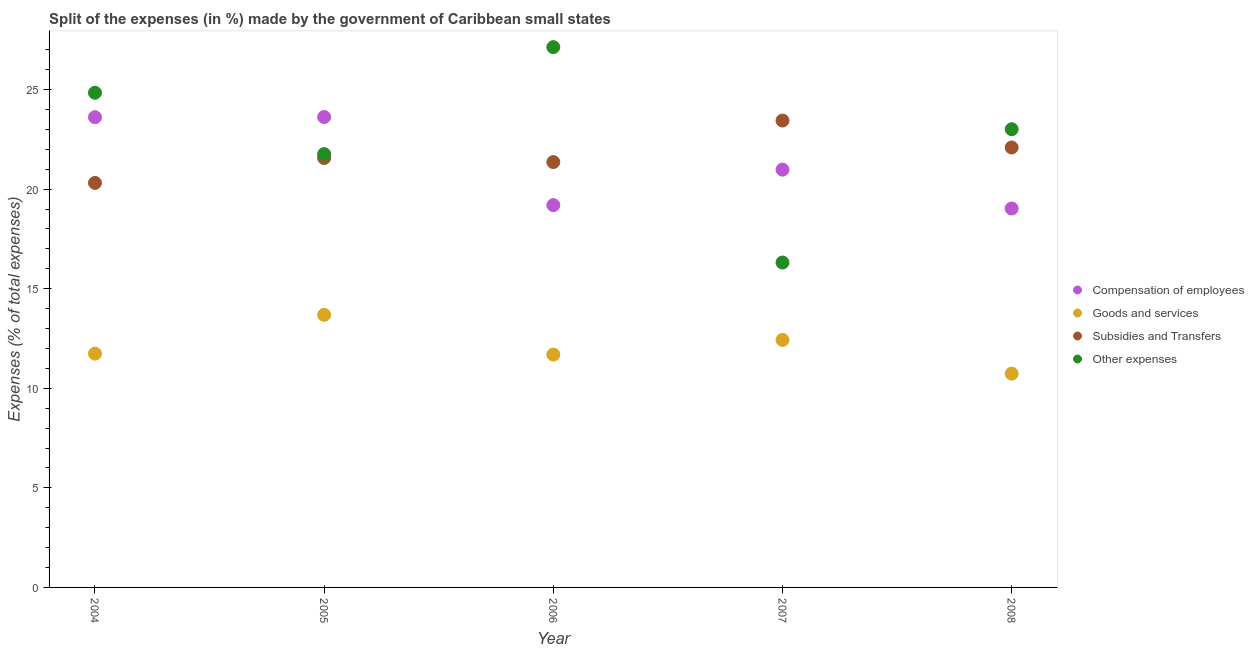How many different coloured dotlines are there?
Ensure brevity in your answer.  4. Is the number of dotlines equal to the number of legend labels?
Make the answer very short. Yes. What is the percentage of amount spent on goods and services in 2006?
Ensure brevity in your answer.  11.69. Across all years, what is the maximum percentage of amount spent on other expenses?
Give a very brief answer. 27.13. Across all years, what is the minimum percentage of amount spent on subsidies?
Offer a terse response. 20.31. In which year was the percentage of amount spent on goods and services maximum?
Make the answer very short. 2005. In which year was the percentage of amount spent on compensation of employees minimum?
Your answer should be compact. 2008. What is the total percentage of amount spent on other expenses in the graph?
Your answer should be compact. 113.04. What is the difference between the percentage of amount spent on goods and services in 2004 and that in 2007?
Make the answer very short. -0.69. What is the difference between the percentage of amount spent on compensation of employees in 2007 and the percentage of amount spent on other expenses in 2004?
Provide a succinct answer. -3.86. What is the average percentage of amount spent on other expenses per year?
Your answer should be compact. 22.61. In the year 2008, what is the difference between the percentage of amount spent on compensation of employees and percentage of amount spent on goods and services?
Ensure brevity in your answer.  8.29. In how many years, is the percentage of amount spent on subsidies greater than 13 %?
Your response must be concise. 5. What is the ratio of the percentage of amount spent on compensation of employees in 2005 to that in 2008?
Give a very brief answer. 1.24. Is the percentage of amount spent on goods and services in 2006 less than that in 2007?
Keep it short and to the point. Yes. Is the difference between the percentage of amount spent on goods and services in 2004 and 2006 greater than the difference between the percentage of amount spent on other expenses in 2004 and 2006?
Offer a terse response. Yes. What is the difference between the highest and the second highest percentage of amount spent on other expenses?
Your response must be concise. 2.29. What is the difference between the highest and the lowest percentage of amount spent on other expenses?
Your answer should be compact. 10.81. In how many years, is the percentage of amount spent on other expenses greater than the average percentage of amount spent on other expenses taken over all years?
Provide a succinct answer. 3. Does the percentage of amount spent on other expenses monotonically increase over the years?
Offer a very short reply. No. Is the percentage of amount spent on goods and services strictly greater than the percentage of amount spent on other expenses over the years?
Your answer should be very brief. No. How many dotlines are there?
Your response must be concise. 4. How many years are there in the graph?
Ensure brevity in your answer.  5. Are the values on the major ticks of Y-axis written in scientific E-notation?
Provide a short and direct response. No. What is the title of the graph?
Keep it short and to the point. Split of the expenses (in %) made by the government of Caribbean small states. What is the label or title of the X-axis?
Offer a terse response. Year. What is the label or title of the Y-axis?
Provide a succinct answer. Expenses (% of total expenses). What is the Expenses (% of total expenses) in Compensation of employees in 2004?
Make the answer very short. 23.61. What is the Expenses (% of total expenses) in Goods and services in 2004?
Your answer should be compact. 11.74. What is the Expenses (% of total expenses) in Subsidies and Transfers in 2004?
Your answer should be very brief. 20.31. What is the Expenses (% of total expenses) of Other expenses in 2004?
Your answer should be compact. 24.84. What is the Expenses (% of total expenses) of Compensation of employees in 2005?
Offer a very short reply. 23.62. What is the Expenses (% of total expenses) in Goods and services in 2005?
Provide a short and direct response. 13.69. What is the Expenses (% of total expenses) in Subsidies and Transfers in 2005?
Your answer should be very brief. 21.56. What is the Expenses (% of total expenses) in Other expenses in 2005?
Make the answer very short. 21.76. What is the Expenses (% of total expenses) in Compensation of employees in 2006?
Offer a very short reply. 19.19. What is the Expenses (% of total expenses) in Goods and services in 2006?
Keep it short and to the point. 11.69. What is the Expenses (% of total expenses) of Subsidies and Transfers in 2006?
Ensure brevity in your answer.  21.36. What is the Expenses (% of total expenses) in Other expenses in 2006?
Give a very brief answer. 27.13. What is the Expenses (% of total expenses) of Compensation of employees in 2007?
Offer a terse response. 20.98. What is the Expenses (% of total expenses) of Goods and services in 2007?
Your answer should be compact. 12.43. What is the Expenses (% of total expenses) in Subsidies and Transfers in 2007?
Your answer should be very brief. 23.44. What is the Expenses (% of total expenses) in Other expenses in 2007?
Your answer should be very brief. 16.31. What is the Expenses (% of total expenses) of Compensation of employees in 2008?
Provide a succinct answer. 19.03. What is the Expenses (% of total expenses) in Goods and services in 2008?
Ensure brevity in your answer.  10.73. What is the Expenses (% of total expenses) in Subsidies and Transfers in 2008?
Your response must be concise. 22.09. What is the Expenses (% of total expenses) of Other expenses in 2008?
Your answer should be compact. 23.01. Across all years, what is the maximum Expenses (% of total expenses) in Compensation of employees?
Keep it short and to the point. 23.62. Across all years, what is the maximum Expenses (% of total expenses) of Goods and services?
Provide a short and direct response. 13.69. Across all years, what is the maximum Expenses (% of total expenses) of Subsidies and Transfers?
Your answer should be compact. 23.44. Across all years, what is the maximum Expenses (% of total expenses) in Other expenses?
Your response must be concise. 27.13. Across all years, what is the minimum Expenses (% of total expenses) in Compensation of employees?
Give a very brief answer. 19.03. Across all years, what is the minimum Expenses (% of total expenses) of Goods and services?
Make the answer very short. 10.73. Across all years, what is the minimum Expenses (% of total expenses) of Subsidies and Transfers?
Offer a very short reply. 20.31. Across all years, what is the minimum Expenses (% of total expenses) in Other expenses?
Give a very brief answer. 16.31. What is the total Expenses (% of total expenses) of Compensation of employees in the graph?
Give a very brief answer. 106.42. What is the total Expenses (% of total expenses) in Goods and services in the graph?
Ensure brevity in your answer.  60.28. What is the total Expenses (% of total expenses) in Subsidies and Transfers in the graph?
Ensure brevity in your answer.  108.76. What is the total Expenses (% of total expenses) of Other expenses in the graph?
Keep it short and to the point. 113.04. What is the difference between the Expenses (% of total expenses) of Compensation of employees in 2004 and that in 2005?
Your answer should be compact. -0.01. What is the difference between the Expenses (% of total expenses) in Goods and services in 2004 and that in 2005?
Give a very brief answer. -1.95. What is the difference between the Expenses (% of total expenses) in Subsidies and Transfers in 2004 and that in 2005?
Give a very brief answer. -1.25. What is the difference between the Expenses (% of total expenses) of Other expenses in 2004 and that in 2005?
Offer a terse response. 3.08. What is the difference between the Expenses (% of total expenses) in Compensation of employees in 2004 and that in 2006?
Make the answer very short. 4.41. What is the difference between the Expenses (% of total expenses) of Goods and services in 2004 and that in 2006?
Make the answer very short. 0.05. What is the difference between the Expenses (% of total expenses) of Subsidies and Transfers in 2004 and that in 2006?
Provide a succinct answer. -1.05. What is the difference between the Expenses (% of total expenses) in Other expenses in 2004 and that in 2006?
Your answer should be compact. -2.29. What is the difference between the Expenses (% of total expenses) of Compensation of employees in 2004 and that in 2007?
Provide a succinct answer. 2.63. What is the difference between the Expenses (% of total expenses) in Goods and services in 2004 and that in 2007?
Your answer should be very brief. -0.69. What is the difference between the Expenses (% of total expenses) of Subsidies and Transfers in 2004 and that in 2007?
Provide a succinct answer. -3.13. What is the difference between the Expenses (% of total expenses) of Other expenses in 2004 and that in 2007?
Provide a short and direct response. 8.53. What is the difference between the Expenses (% of total expenses) in Compensation of employees in 2004 and that in 2008?
Keep it short and to the point. 4.58. What is the difference between the Expenses (% of total expenses) of Goods and services in 2004 and that in 2008?
Provide a short and direct response. 1.01. What is the difference between the Expenses (% of total expenses) of Subsidies and Transfers in 2004 and that in 2008?
Give a very brief answer. -1.78. What is the difference between the Expenses (% of total expenses) in Other expenses in 2004 and that in 2008?
Make the answer very short. 1.83. What is the difference between the Expenses (% of total expenses) in Compensation of employees in 2005 and that in 2006?
Your response must be concise. 4.42. What is the difference between the Expenses (% of total expenses) of Goods and services in 2005 and that in 2006?
Keep it short and to the point. 1.99. What is the difference between the Expenses (% of total expenses) in Subsidies and Transfers in 2005 and that in 2006?
Provide a short and direct response. 0.2. What is the difference between the Expenses (% of total expenses) in Other expenses in 2005 and that in 2006?
Give a very brief answer. -5.37. What is the difference between the Expenses (% of total expenses) in Compensation of employees in 2005 and that in 2007?
Give a very brief answer. 2.64. What is the difference between the Expenses (% of total expenses) of Goods and services in 2005 and that in 2007?
Make the answer very short. 1.26. What is the difference between the Expenses (% of total expenses) in Subsidies and Transfers in 2005 and that in 2007?
Your answer should be compact. -1.88. What is the difference between the Expenses (% of total expenses) of Other expenses in 2005 and that in 2007?
Your answer should be compact. 5.44. What is the difference between the Expenses (% of total expenses) of Compensation of employees in 2005 and that in 2008?
Offer a very short reply. 4.59. What is the difference between the Expenses (% of total expenses) in Goods and services in 2005 and that in 2008?
Make the answer very short. 2.95. What is the difference between the Expenses (% of total expenses) of Subsidies and Transfers in 2005 and that in 2008?
Ensure brevity in your answer.  -0.53. What is the difference between the Expenses (% of total expenses) of Other expenses in 2005 and that in 2008?
Offer a very short reply. -1.25. What is the difference between the Expenses (% of total expenses) of Compensation of employees in 2006 and that in 2007?
Offer a terse response. -1.78. What is the difference between the Expenses (% of total expenses) in Goods and services in 2006 and that in 2007?
Offer a very short reply. -0.74. What is the difference between the Expenses (% of total expenses) of Subsidies and Transfers in 2006 and that in 2007?
Your response must be concise. -2.08. What is the difference between the Expenses (% of total expenses) of Other expenses in 2006 and that in 2007?
Make the answer very short. 10.81. What is the difference between the Expenses (% of total expenses) in Compensation of employees in 2006 and that in 2008?
Your response must be concise. 0.17. What is the difference between the Expenses (% of total expenses) of Subsidies and Transfers in 2006 and that in 2008?
Offer a very short reply. -0.73. What is the difference between the Expenses (% of total expenses) of Other expenses in 2006 and that in 2008?
Provide a succinct answer. 4.12. What is the difference between the Expenses (% of total expenses) in Compensation of employees in 2007 and that in 2008?
Ensure brevity in your answer.  1.95. What is the difference between the Expenses (% of total expenses) in Goods and services in 2007 and that in 2008?
Your answer should be compact. 1.7. What is the difference between the Expenses (% of total expenses) of Subsidies and Transfers in 2007 and that in 2008?
Provide a short and direct response. 1.35. What is the difference between the Expenses (% of total expenses) in Other expenses in 2007 and that in 2008?
Offer a terse response. -6.69. What is the difference between the Expenses (% of total expenses) of Compensation of employees in 2004 and the Expenses (% of total expenses) of Goods and services in 2005?
Provide a succinct answer. 9.92. What is the difference between the Expenses (% of total expenses) of Compensation of employees in 2004 and the Expenses (% of total expenses) of Subsidies and Transfers in 2005?
Your answer should be very brief. 2.05. What is the difference between the Expenses (% of total expenses) in Compensation of employees in 2004 and the Expenses (% of total expenses) in Other expenses in 2005?
Give a very brief answer. 1.85. What is the difference between the Expenses (% of total expenses) in Goods and services in 2004 and the Expenses (% of total expenses) in Subsidies and Transfers in 2005?
Your answer should be very brief. -9.82. What is the difference between the Expenses (% of total expenses) of Goods and services in 2004 and the Expenses (% of total expenses) of Other expenses in 2005?
Give a very brief answer. -10.02. What is the difference between the Expenses (% of total expenses) of Subsidies and Transfers in 2004 and the Expenses (% of total expenses) of Other expenses in 2005?
Your answer should be compact. -1.45. What is the difference between the Expenses (% of total expenses) in Compensation of employees in 2004 and the Expenses (% of total expenses) in Goods and services in 2006?
Make the answer very short. 11.92. What is the difference between the Expenses (% of total expenses) in Compensation of employees in 2004 and the Expenses (% of total expenses) in Subsidies and Transfers in 2006?
Provide a succinct answer. 2.25. What is the difference between the Expenses (% of total expenses) in Compensation of employees in 2004 and the Expenses (% of total expenses) in Other expenses in 2006?
Provide a succinct answer. -3.52. What is the difference between the Expenses (% of total expenses) in Goods and services in 2004 and the Expenses (% of total expenses) in Subsidies and Transfers in 2006?
Your answer should be compact. -9.62. What is the difference between the Expenses (% of total expenses) in Goods and services in 2004 and the Expenses (% of total expenses) in Other expenses in 2006?
Ensure brevity in your answer.  -15.39. What is the difference between the Expenses (% of total expenses) in Subsidies and Transfers in 2004 and the Expenses (% of total expenses) in Other expenses in 2006?
Your answer should be compact. -6.82. What is the difference between the Expenses (% of total expenses) of Compensation of employees in 2004 and the Expenses (% of total expenses) of Goods and services in 2007?
Offer a terse response. 11.18. What is the difference between the Expenses (% of total expenses) of Compensation of employees in 2004 and the Expenses (% of total expenses) of Subsidies and Transfers in 2007?
Give a very brief answer. 0.17. What is the difference between the Expenses (% of total expenses) in Compensation of employees in 2004 and the Expenses (% of total expenses) in Other expenses in 2007?
Make the answer very short. 7.3. What is the difference between the Expenses (% of total expenses) of Goods and services in 2004 and the Expenses (% of total expenses) of Subsidies and Transfers in 2007?
Give a very brief answer. -11.7. What is the difference between the Expenses (% of total expenses) in Goods and services in 2004 and the Expenses (% of total expenses) in Other expenses in 2007?
Give a very brief answer. -4.57. What is the difference between the Expenses (% of total expenses) of Subsidies and Transfers in 2004 and the Expenses (% of total expenses) of Other expenses in 2007?
Offer a terse response. 4. What is the difference between the Expenses (% of total expenses) of Compensation of employees in 2004 and the Expenses (% of total expenses) of Goods and services in 2008?
Your answer should be compact. 12.88. What is the difference between the Expenses (% of total expenses) of Compensation of employees in 2004 and the Expenses (% of total expenses) of Subsidies and Transfers in 2008?
Provide a succinct answer. 1.52. What is the difference between the Expenses (% of total expenses) in Compensation of employees in 2004 and the Expenses (% of total expenses) in Other expenses in 2008?
Your response must be concise. 0.6. What is the difference between the Expenses (% of total expenses) of Goods and services in 2004 and the Expenses (% of total expenses) of Subsidies and Transfers in 2008?
Ensure brevity in your answer.  -10.35. What is the difference between the Expenses (% of total expenses) of Goods and services in 2004 and the Expenses (% of total expenses) of Other expenses in 2008?
Your answer should be compact. -11.27. What is the difference between the Expenses (% of total expenses) of Subsidies and Transfers in 2004 and the Expenses (% of total expenses) of Other expenses in 2008?
Your response must be concise. -2.69. What is the difference between the Expenses (% of total expenses) in Compensation of employees in 2005 and the Expenses (% of total expenses) in Goods and services in 2006?
Keep it short and to the point. 11.93. What is the difference between the Expenses (% of total expenses) of Compensation of employees in 2005 and the Expenses (% of total expenses) of Subsidies and Transfers in 2006?
Offer a very short reply. 2.26. What is the difference between the Expenses (% of total expenses) of Compensation of employees in 2005 and the Expenses (% of total expenses) of Other expenses in 2006?
Offer a terse response. -3.51. What is the difference between the Expenses (% of total expenses) of Goods and services in 2005 and the Expenses (% of total expenses) of Subsidies and Transfers in 2006?
Keep it short and to the point. -7.67. What is the difference between the Expenses (% of total expenses) in Goods and services in 2005 and the Expenses (% of total expenses) in Other expenses in 2006?
Ensure brevity in your answer.  -13.44. What is the difference between the Expenses (% of total expenses) in Subsidies and Transfers in 2005 and the Expenses (% of total expenses) in Other expenses in 2006?
Make the answer very short. -5.57. What is the difference between the Expenses (% of total expenses) in Compensation of employees in 2005 and the Expenses (% of total expenses) in Goods and services in 2007?
Your response must be concise. 11.19. What is the difference between the Expenses (% of total expenses) of Compensation of employees in 2005 and the Expenses (% of total expenses) of Subsidies and Transfers in 2007?
Offer a terse response. 0.18. What is the difference between the Expenses (% of total expenses) of Compensation of employees in 2005 and the Expenses (% of total expenses) of Other expenses in 2007?
Provide a succinct answer. 7.31. What is the difference between the Expenses (% of total expenses) in Goods and services in 2005 and the Expenses (% of total expenses) in Subsidies and Transfers in 2007?
Provide a short and direct response. -9.75. What is the difference between the Expenses (% of total expenses) of Goods and services in 2005 and the Expenses (% of total expenses) of Other expenses in 2007?
Provide a succinct answer. -2.63. What is the difference between the Expenses (% of total expenses) in Subsidies and Transfers in 2005 and the Expenses (% of total expenses) in Other expenses in 2007?
Make the answer very short. 5.25. What is the difference between the Expenses (% of total expenses) in Compensation of employees in 2005 and the Expenses (% of total expenses) in Goods and services in 2008?
Offer a very short reply. 12.89. What is the difference between the Expenses (% of total expenses) of Compensation of employees in 2005 and the Expenses (% of total expenses) of Subsidies and Transfers in 2008?
Your answer should be compact. 1.53. What is the difference between the Expenses (% of total expenses) of Compensation of employees in 2005 and the Expenses (% of total expenses) of Other expenses in 2008?
Provide a succinct answer. 0.61. What is the difference between the Expenses (% of total expenses) in Goods and services in 2005 and the Expenses (% of total expenses) in Subsidies and Transfers in 2008?
Offer a very short reply. -8.4. What is the difference between the Expenses (% of total expenses) of Goods and services in 2005 and the Expenses (% of total expenses) of Other expenses in 2008?
Your answer should be compact. -9.32. What is the difference between the Expenses (% of total expenses) in Subsidies and Transfers in 2005 and the Expenses (% of total expenses) in Other expenses in 2008?
Give a very brief answer. -1.45. What is the difference between the Expenses (% of total expenses) in Compensation of employees in 2006 and the Expenses (% of total expenses) in Goods and services in 2007?
Make the answer very short. 6.77. What is the difference between the Expenses (% of total expenses) of Compensation of employees in 2006 and the Expenses (% of total expenses) of Subsidies and Transfers in 2007?
Ensure brevity in your answer.  -4.25. What is the difference between the Expenses (% of total expenses) of Compensation of employees in 2006 and the Expenses (% of total expenses) of Other expenses in 2007?
Your answer should be very brief. 2.88. What is the difference between the Expenses (% of total expenses) in Goods and services in 2006 and the Expenses (% of total expenses) in Subsidies and Transfers in 2007?
Offer a terse response. -11.75. What is the difference between the Expenses (% of total expenses) in Goods and services in 2006 and the Expenses (% of total expenses) in Other expenses in 2007?
Give a very brief answer. -4.62. What is the difference between the Expenses (% of total expenses) of Subsidies and Transfers in 2006 and the Expenses (% of total expenses) of Other expenses in 2007?
Your answer should be very brief. 5.05. What is the difference between the Expenses (% of total expenses) of Compensation of employees in 2006 and the Expenses (% of total expenses) of Goods and services in 2008?
Offer a very short reply. 8.46. What is the difference between the Expenses (% of total expenses) in Compensation of employees in 2006 and the Expenses (% of total expenses) in Subsidies and Transfers in 2008?
Your answer should be compact. -2.89. What is the difference between the Expenses (% of total expenses) in Compensation of employees in 2006 and the Expenses (% of total expenses) in Other expenses in 2008?
Your answer should be very brief. -3.81. What is the difference between the Expenses (% of total expenses) of Goods and services in 2006 and the Expenses (% of total expenses) of Subsidies and Transfers in 2008?
Give a very brief answer. -10.4. What is the difference between the Expenses (% of total expenses) in Goods and services in 2006 and the Expenses (% of total expenses) in Other expenses in 2008?
Your response must be concise. -11.31. What is the difference between the Expenses (% of total expenses) in Subsidies and Transfers in 2006 and the Expenses (% of total expenses) in Other expenses in 2008?
Offer a terse response. -1.65. What is the difference between the Expenses (% of total expenses) in Compensation of employees in 2007 and the Expenses (% of total expenses) in Goods and services in 2008?
Give a very brief answer. 10.24. What is the difference between the Expenses (% of total expenses) of Compensation of employees in 2007 and the Expenses (% of total expenses) of Subsidies and Transfers in 2008?
Your answer should be very brief. -1.11. What is the difference between the Expenses (% of total expenses) of Compensation of employees in 2007 and the Expenses (% of total expenses) of Other expenses in 2008?
Offer a very short reply. -2.03. What is the difference between the Expenses (% of total expenses) in Goods and services in 2007 and the Expenses (% of total expenses) in Subsidies and Transfers in 2008?
Offer a terse response. -9.66. What is the difference between the Expenses (% of total expenses) of Goods and services in 2007 and the Expenses (% of total expenses) of Other expenses in 2008?
Offer a terse response. -10.58. What is the difference between the Expenses (% of total expenses) of Subsidies and Transfers in 2007 and the Expenses (% of total expenses) of Other expenses in 2008?
Your answer should be very brief. 0.44. What is the average Expenses (% of total expenses) of Compensation of employees per year?
Offer a very short reply. 21.28. What is the average Expenses (% of total expenses) of Goods and services per year?
Make the answer very short. 12.06. What is the average Expenses (% of total expenses) of Subsidies and Transfers per year?
Ensure brevity in your answer.  21.75. What is the average Expenses (% of total expenses) in Other expenses per year?
Provide a succinct answer. 22.61. In the year 2004, what is the difference between the Expenses (% of total expenses) of Compensation of employees and Expenses (% of total expenses) of Goods and services?
Your answer should be very brief. 11.87. In the year 2004, what is the difference between the Expenses (% of total expenses) of Compensation of employees and Expenses (% of total expenses) of Subsidies and Transfers?
Offer a very short reply. 3.3. In the year 2004, what is the difference between the Expenses (% of total expenses) of Compensation of employees and Expenses (% of total expenses) of Other expenses?
Your answer should be very brief. -1.23. In the year 2004, what is the difference between the Expenses (% of total expenses) of Goods and services and Expenses (% of total expenses) of Subsidies and Transfers?
Offer a very short reply. -8.57. In the year 2004, what is the difference between the Expenses (% of total expenses) of Goods and services and Expenses (% of total expenses) of Other expenses?
Make the answer very short. -13.1. In the year 2004, what is the difference between the Expenses (% of total expenses) of Subsidies and Transfers and Expenses (% of total expenses) of Other expenses?
Your answer should be very brief. -4.53. In the year 2005, what is the difference between the Expenses (% of total expenses) of Compensation of employees and Expenses (% of total expenses) of Goods and services?
Make the answer very short. 9.93. In the year 2005, what is the difference between the Expenses (% of total expenses) of Compensation of employees and Expenses (% of total expenses) of Subsidies and Transfers?
Provide a succinct answer. 2.06. In the year 2005, what is the difference between the Expenses (% of total expenses) in Compensation of employees and Expenses (% of total expenses) in Other expenses?
Your response must be concise. 1.86. In the year 2005, what is the difference between the Expenses (% of total expenses) of Goods and services and Expenses (% of total expenses) of Subsidies and Transfers?
Keep it short and to the point. -7.87. In the year 2005, what is the difference between the Expenses (% of total expenses) of Goods and services and Expenses (% of total expenses) of Other expenses?
Make the answer very short. -8.07. In the year 2005, what is the difference between the Expenses (% of total expenses) of Subsidies and Transfers and Expenses (% of total expenses) of Other expenses?
Your answer should be compact. -0.2. In the year 2006, what is the difference between the Expenses (% of total expenses) in Compensation of employees and Expenses (% of total expenses) in Goods and services?
Ensure brevity in your answer.  7.5. In the year 2006, what is the difference between the Expenses (% of total expenses) in Compensation of employees and Expenses (% of total expenses) in Subsidies and Transfers?
Provide a short and direct response. -2.16. In the year 2006, what is the difference between the Expenses (% of total expenses) in Compensation of employees and Expenses (% of total expenses) in Other expenses?
Your response must be concise. -7.93. In the year 2006, what is the difference between the Expenses (% of total expenses) in Goods and services and Expenses (% of total expenses) in Subsidies and Transfers?
Provide a short and direct response. -9.67. In the year 2006, what is the difference between the Expenses (% of total expenses) in Goods and services and Expenses (% of total expenses) in Other expenses?
Your answer should be very brief. -15.43. In the year 2006, what is the difference between the Expenses (% of total expenses) of Subsidies and Transfers and Expenses (% of total expenses) of Other expenses?
Provide a succinct answer. -5.77. In the year 2007, what is the difference between the Expenses (% of total expenses) of Compensation of employees and Expenses (% of total expenses) of Goods and services?
Provide a short and direct response. 8.55. In the year 2007, what is the difference between the Expenses (% of total expenses) of Compensation of employees and Expenses (% of total expenses) of Subsidies and Transfers?
Provide a short and direct response. -2.47. In the year 2007, what is the difference between the Expenses (% of total expenses) in Compensation of employees and Expenses (% of total expenses) in Other expenses?
Your response must be concise. 4.66. In the year 2007, what is the difference between the Expenses (% of total expenses) in Goods and services and Expenses (% of total expenses) in Subsidies and Transfers?
Your response must be concise. -11.01. In the year 2007, what is the difference between the Expenses (% of total expenses) in Goods and services and Expenses (% of total expenses) in Other expenses?
Keep it short and to the point. -3.88. In the year 2007, what is the difference between the Expenses (% of total expenses) in Subsidies and Transfers and Expenses (% of total expenses) in Other expenses?
Offer a very short reply. 7.13. In the year 2008, what is the difference between the Expenses (% of total expenses) of Compensation of employees and Expenses (% of total expenses) of Goods and services?
Give a very brief answer. 8.29. In the year 2008, what is the difference between the Expenses (% of total expenses) of Compensation of employees and Expenses (% of total expenses) of Subsidies and Transfers?
Your answer should be very brief. -3.06. In the year 2008, what is the difference between the Expenses (% of total expenses) in Compensation of employees and Expenses (% of total expenses) in Other expenses?
Provide a short and direct response. -3.98. In the year 2008, what is the difference between the Expenses (% of total expenses) of Goods and services and Expenses (% of total expenses) of Subsidies and Transfers?
Keep it short and to the point. -11.36. In the year 2008, what is the difference between the Expenses (% of total expenses) of Goods and services and Expenses (% of total expenses) of Other expenses?
Your response must be concise. -12.27. In the year 2008, what is the difference between the Expenses (% of total expenses) in Subsidies and Transfers and Expenses (% of total expenses) in Other expenses?
Your response must be concise. -0.92. What is the ratio of the Expenses (% of total expenses) in Compensation of employees in 2004 to that in 2005?
Provide a succinct answer. 1. What is the ratio of the Expenses (% of total expenses) of Goods and services in 2004 to that in 2005?
Provide a succinct answer. 0.86. What is the ratio of the Expenses (% of total expenses) in Subsidies and Transfers in 2004 to that in 2005?
Keep it short and to the point. 0.94. What is the ratio of the Expenses (% of total expenses) in Other expenses in 2004 to that in 2005?
Provide a succinct answer. 1.14. What is the ratio of the Expenses (% of total expenses) of Compensation of employees in 2004 to that in 2006?
Provide a succinct answer. 1.23. What is the ratio of the Expenses (% of total expenses) of Goods and services in 2004 to that in 2006?
Ensure brevity in your answer.  1. What is the ratio of the Expenses (% of total expenses) of Subsidies and Transfers in 2004 to that in 2006?
Your answer should be compact. 0.95. What is the ratio of the Expenses (% of total expenses) of Other expenses in 2004 to that in 2006?
Your response must be concise. 0.92. What is the ratio of the Expenses (% of total expenses) of Compensation of employees in 2004 to that in 2007?
Keep it short and to the point. 1.13. What is the ratio of the Expenses (% of total expenses) of Subsidies and Transfers in 2004 to that in 2007?
Keep it short and to the point. 0.87. What is the ratio of the Expenses (% of total expenses) of Other expenses in 2004 to that in 2007?
Keep it short and to the point. 1.52. What is the ratio of the Expenses (% of total expenses) of Compensation of employees in 2004 to that in 2008?
Keep it short and to the point. 1.24. What is the ratio of the Expenses (% of total expenses) of Goods and services in 2004 to that in 2008?
Provide a short and direct response. 1.09. What is the ratio of the Expenses (% of total expenses) in Subsidies and Transfers in 2004 to that in 2008?
Provide a short and direct response. 0.92. What is the ratio of the Expenses (% of total expenses) in Other expenses in 2004 to that in 2008?
Your answer should be compact. 1.08. What is the ratio of the Expenses (% of total expenses) of Compensation of employees in 2005 to that in 2006?
Keep it short and to the point. 1.23. What is the ratio of the Expenses (% of total expenses) of Goods and services in 2005 to that in 2006?
Ensure brevity in your answer.  1.17. What is the ratio of the Expenses (% of total expenses) in Subsidies and Transfers in 2005 to that in 2006?
Make the answer very short. 1.01. What is the ratio of the Expenses (% of total expenses) of Other expenses in 2005 to that in 2006?
Offer a terse response. 0.8. What is the ratio of the Expenses (% of total expenses) of Compensation of employees in 2005 to that in 2007?
Your response must be concise. 1.13. What is the ratio of the Expenses (% of total expenses) of Goods and services in 2005 to that in 2007?
Give a very brief answer. 1.1. What is the ratio of the Expenses (% of total expenses) in Subsidies and Transfers in 2005 to that in 2007?
Your response must be concise. 0.92. What is the ratio of the Expenses (% of total expenses) in Other expenses in 2005 to that in 2007?
Provide a succinct answer. 1.33. What is the ratio of the Expenses (% of total expenses) of Compensation of employees in 2005 to that in 2008?
Provide a short and direct response. 1.24. What is the ratio of the Expenses (% of total expenses) in Goods and services in 2005 to that in 2008?
Offer a terse response. 1.28. What is the ratio of the Expenses (% of total expenses) of Subsidies and Transfers in 2005 to that in 2008?
Offer a very short reply. 0.98. What is the ratio of the Expenses (% of total expenses) of Other expenses in 2005 to that in 2008?
Offer a terse response. 0.95. What is the ratio of the Expenses (% of total expenses) of Compensation of employees in 2006 to that in 2007?
Offer a very short reply. 0.92. What is the ratio of the Expenses (% of total expenses) in Goods and services in 2006 to that in 2007?
Make the answer very short. 0.94. What is the ratio of the Expenses (% of total expenses) of Subsidies and Transfers in 2006 to that in 2007?
Give a very brief answer. 0.91. What is the ratio of the Expenses (% of total expenses) of Other expenses in 2006 to that in 2007?
Offer a very short reply. 1.66. What is the ratio of the Expenses (% of total expenses) of Compensation of employees in 2006 to that in 2008?
Keep it short and to the point. 1.01. What is the ratio of the Expenses (% of total expenses) in Goods and services in 2006 to that in 2008?
Provide a succinct answer. 1.09. What is the ratio of the Expenses (% of total expenses) in Subsidies and Transfers in 2006 to that in 2008?
Your response must be concise. 0.97. What is the ratio of the Expenses (% of total expenses) in Other expenses in 2006 to that in 2008?
Provide a short and direct response. 1.18. What is the ratio of the Expenses (% of total expenses) of Compensation of employees in 2007 to that in 2008?
Give a very brief answer. 1.1. What is the ratio of the Expenses (% of total expenses) in Goods and services in 2007 to that in 2008?
Provide a succinct answer. 1.16. What is the ratio of the Expenses (% of total expenses) of Subsidies and Transfers in 2007 to that in 2008?
Offer a terse response. 1.06. What is the ratio of the Expenses (% of total expenses) in Other expenses in 2007 to that in 2008?
Provide a succinct answer. 0.71. What is the difference between the highest and the second highest Expenses (% of total expenses) in Compensation of employees?
Make the answer very short. 0.01. What is the difference between the highest and the second highest Expenses (% of total expenses) of Goods and services?
Offer a terse response. 1.26. What is the difference between the highest and the second highest Expenses (% of total expenses) in Subsidies and Transfers?
Make the answer very short. 1.35. What is the difference between the highest and the second highest Expenses (% of total expenses) in Other expenses?
Provide a succinct answer. 2.29. What is the difference between the highest and the lowest Expenses (% of total expenses) of Compensation of employees?
Provide a short and direct response. 4.59. What is the difference between the highest and the lowest Expenses (% of total expenses) in Goods and services?
Your answer should be very brief. 2.95. What is the difference between the highest and the lowest Expenses (% of total expenses) of Subsidies and Transfers?
Your answer should be very brief. 3.13. What is the difference between the highest and the lowest Expenses (% of total expenses) of Other expenses?
Keep it short and to the point. 10.81. 